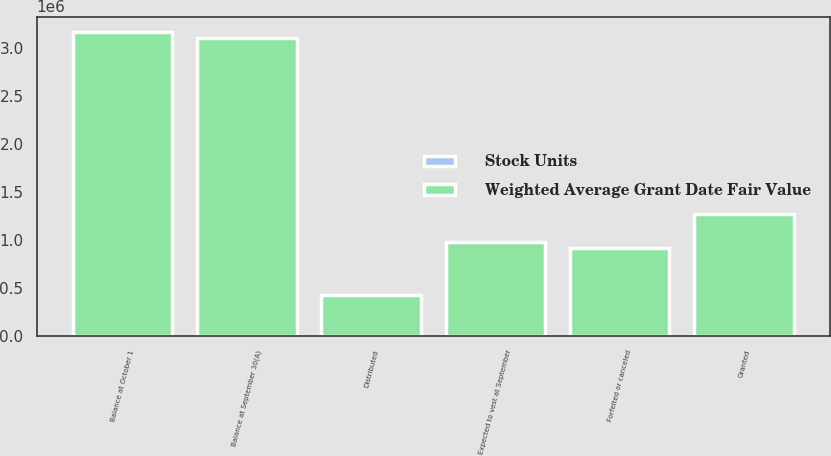Convert chart. <chart><loc_0><loc_0><loc_500><loc_500><stacked_bar_chart><ecel><fcel>Balance at October 1<fcel>Granted<fcel>Distributed<fcel>Forfeited or canceled<fcel>Balance at September 30(A)<fcel>Expected to vest at September<nl><fcel>Weighted Average Grant Date Fair Value<fcel>3.1673e+06<fcel>1.2714e+06<fcel>421914<fcel>917911<fcel>3.09887e+06<fcel>982690<nl><fcel>Stock Units<fcel>69.98<fcel>62.5<fcel>57.49<fcel>60.55<fcel>71.4<fcel>70.86<nl></chart> 